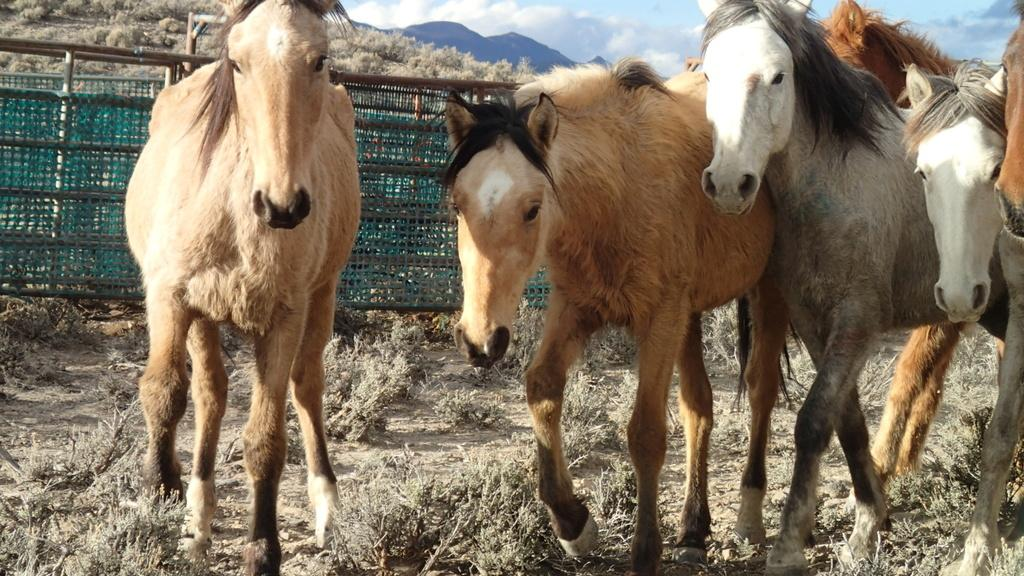What type of animals can be seen in the image? There are brown horses in the image. What is the terrain like where the horses are walking? The horses are walking on dry grassland. What can be seen in the background of the image? There is a fence and hills in the background of the image. What is visible in the sky in the image? The sky is visible in the image, and clouds are present. What type of finger can be seen in the image? There are no fingers present in the image; it features brown horses walking on dry grassland with a fence and hills in the background. 